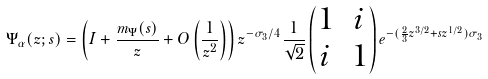Convert formula to latex. <formula><loc_0><loc_0><loc_500><loc_500>\Psi _ { \alpha } ( z ; s ) = \left ( I + \frac { m _ { \Psi } ( s ) } { z } + O \left ( \frac { 1 } { z ^ { 2 } } \right ) \right ) z ^ { - \sigma _ { 3 } / 4 } \frac { 1 } { \sqrt { 2 } } \begin{pmatrix} 1 & i \\ i & 1 \end{pmatrix} e ^ { - ( \frac { 2 } { 3 } z ^ { 3 / 2 } + s z ^ { 1 / 2 } ) \sigma _ { 3 } }</formula> 